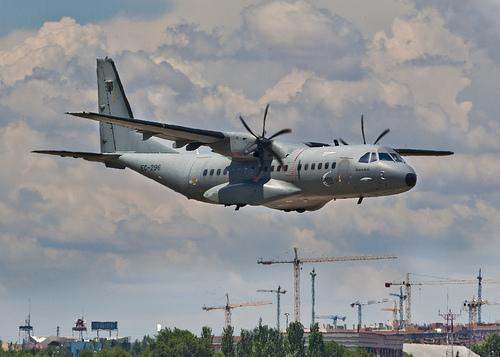How many propellers does the plane have?
Give a very brief answer. 2. 